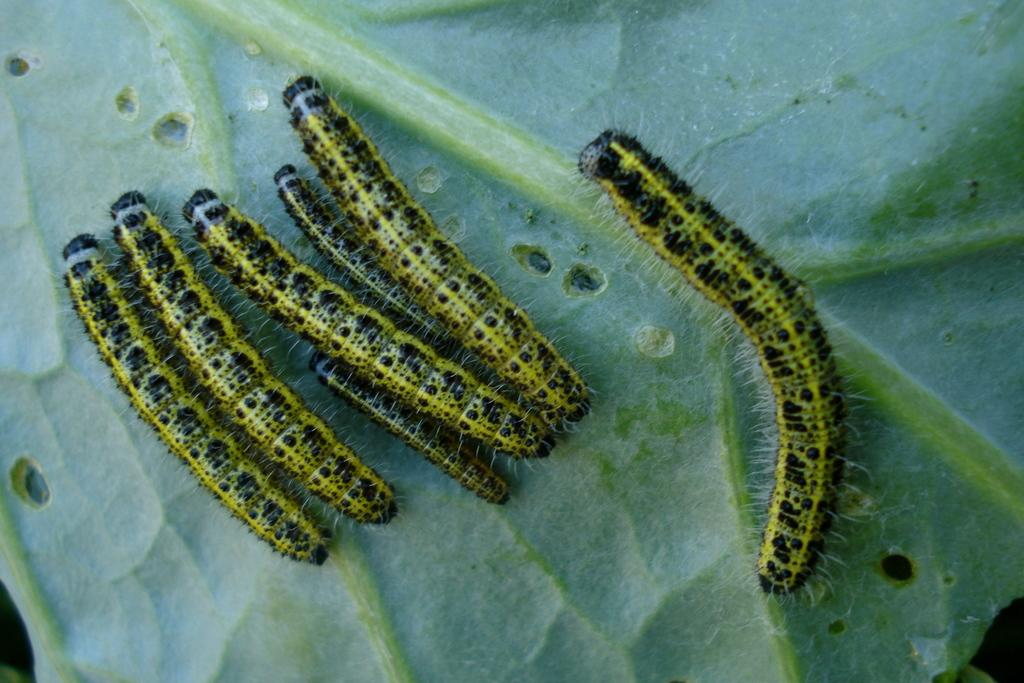What type of animals are in the image? There are caterpillars in the image. Where are the caterpillars located? The caterpillars are on a green leaf. What type of tool is being used by the caterpillars in the image? There is no tool present in the image; the caterpillars are on a green leaf. 